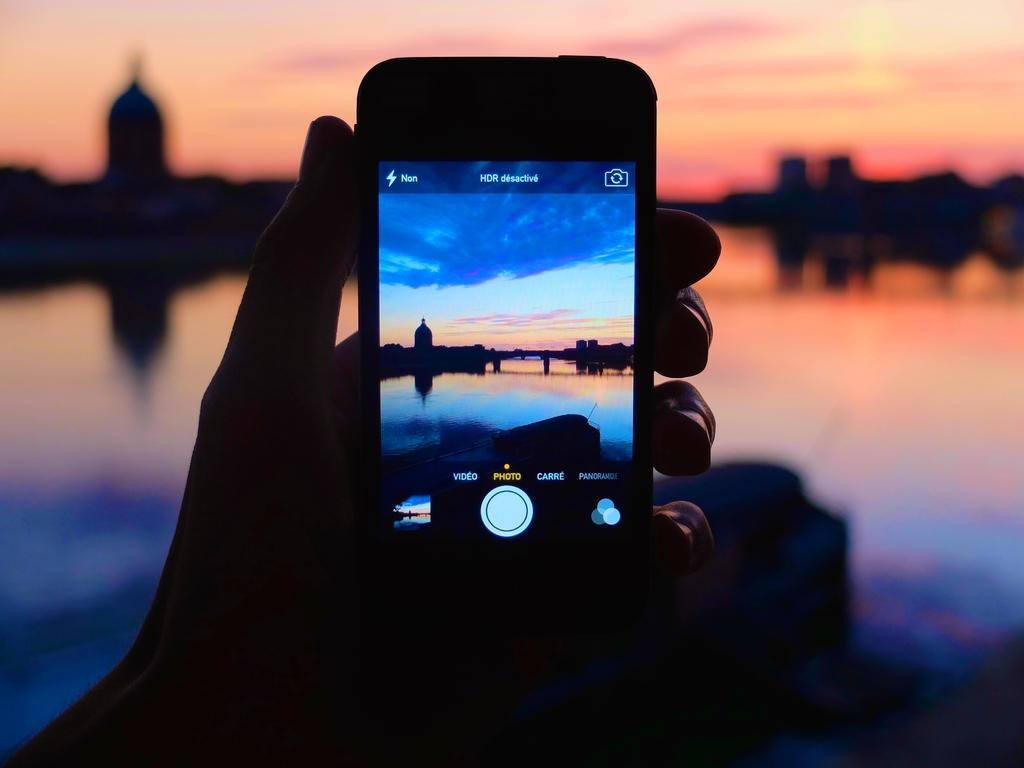Provide a one-sentence caption for the provided image. A person is holding up a cell phone that is in photo mode. 